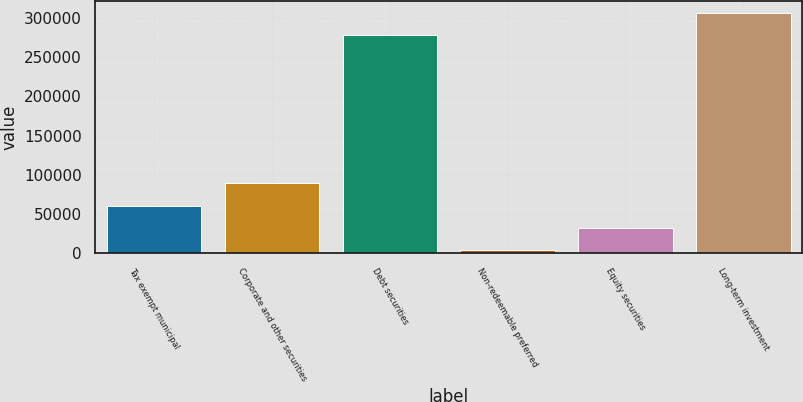Convert chart to OTSL. <chart><loc_0><loc_0><loc_500><loc_500><bar_chart><fcel>Tax exempt municipal<fcel>Corporate and other securities<fcel>Debt securities<fcel>Non-redeemable preferred<fcel>Equity securities<fcel>Long-term investment<nl><fcel>60515.4<fcel>88912.6<fcel>277864<fcel>3721<fcel>32118.2<fcel>306261<nl></chart> 